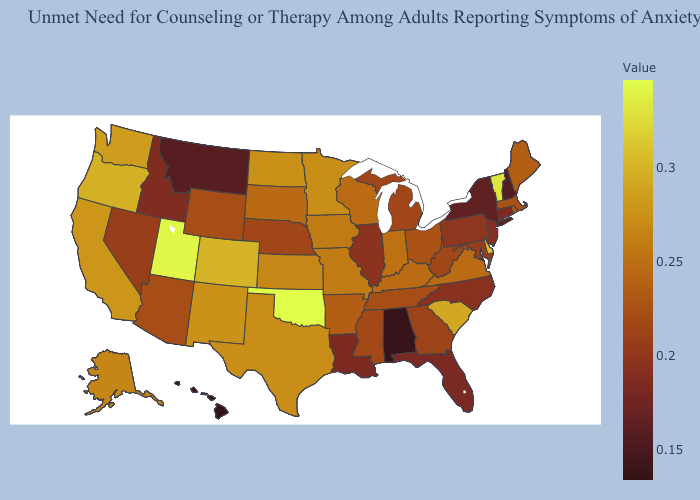Which states have the lowest value in the South?
Write a very short answer. Alabama. Among the states that border Tennessee , does North Carolina have the highest value?
Write a very short answer. No. Does Michigan have the highest value in the MidWest?
Quick response, please. No. Does Kansas have the lowest value in the MidWest?
Keep it brief. No. Which states have the highest value in the USA?
Keep it brief. Oklahoma. 